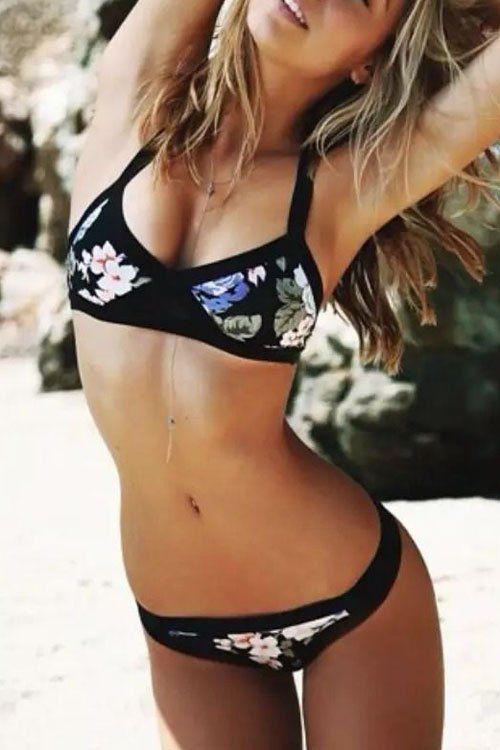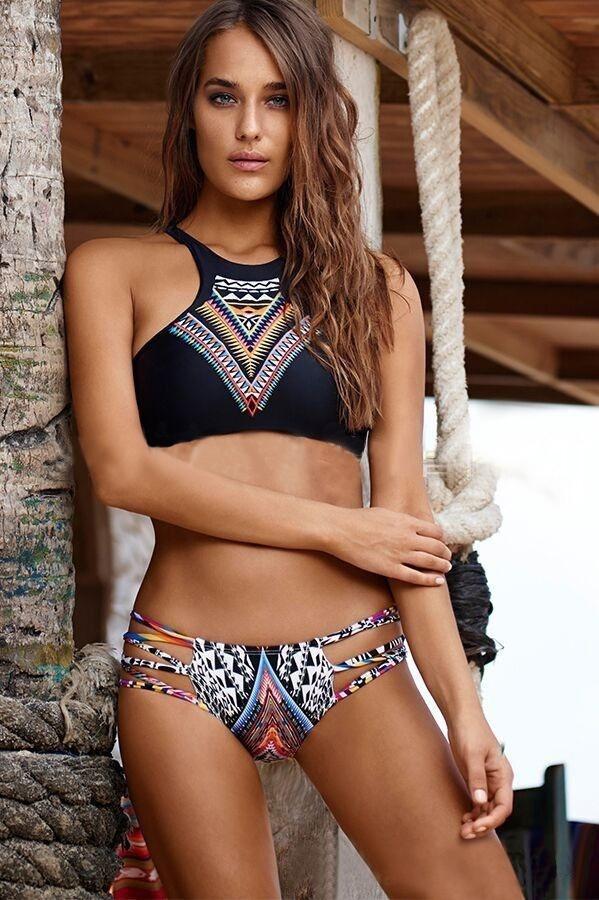The first image is the image on the left, the second image is the image on the right. Considering the images on both sides, is "The swimsuit in the image on the left has a floral print." valid? Answer yes or no. Yes. 